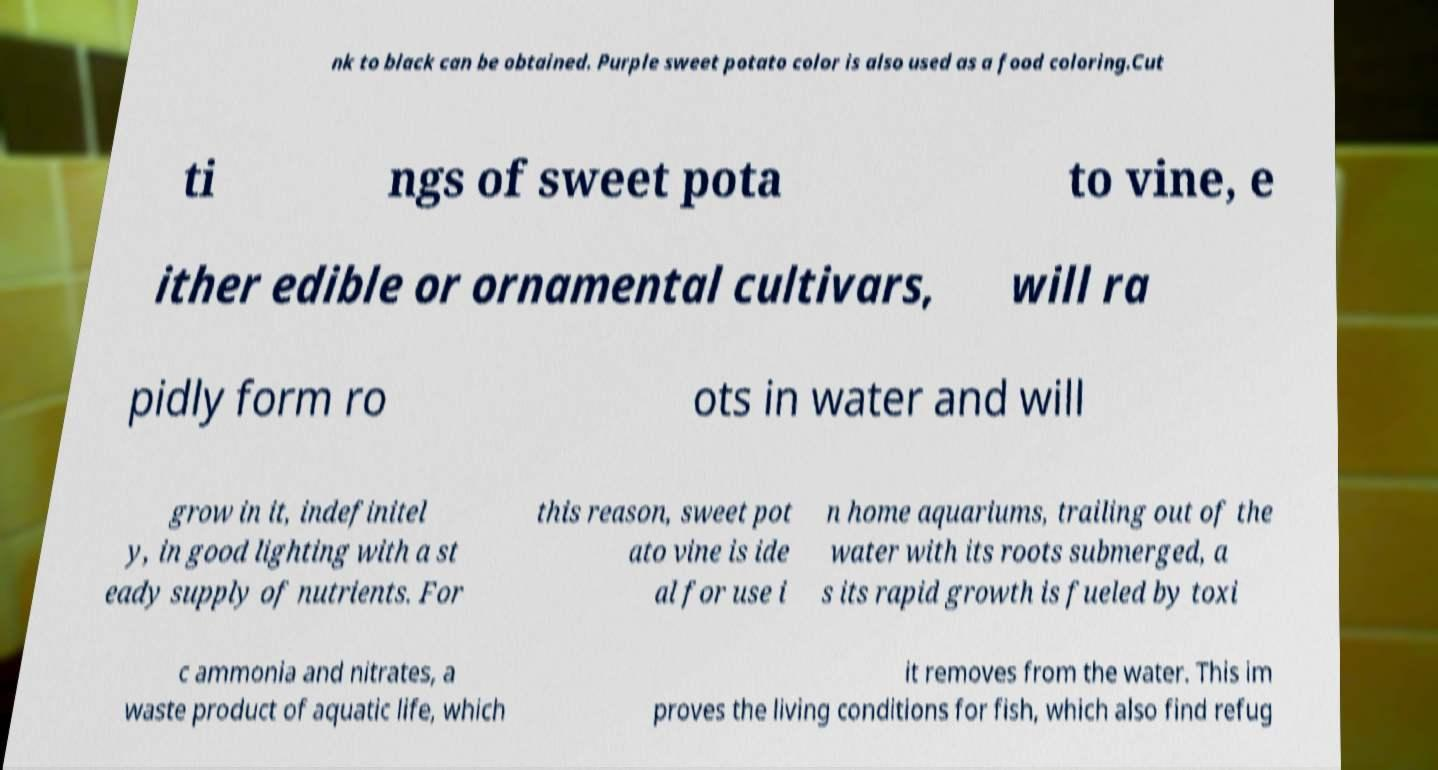Please read and relay the text visible in this image. What does it say? nk to black can be obtained. Purple sweet potato color is also used as a food coloring.Cut ti ngs of sweet pota to vine, e ither edible or ornamental cultivars, will ra pidly form ro ots in water and will grow in it, indefinitel y, in good lighting with a st eady supply of nutrients. For this reason, sweet pot ato vine is ide al for use i n home aquariums, trailing out of the water with its roots submerged, a s its rapid growth is fueled by toxi c ammonia and nitrates, a waste product of aquatic life, which it removes from the water. This im proves the living conditions for fish, which also find refug 